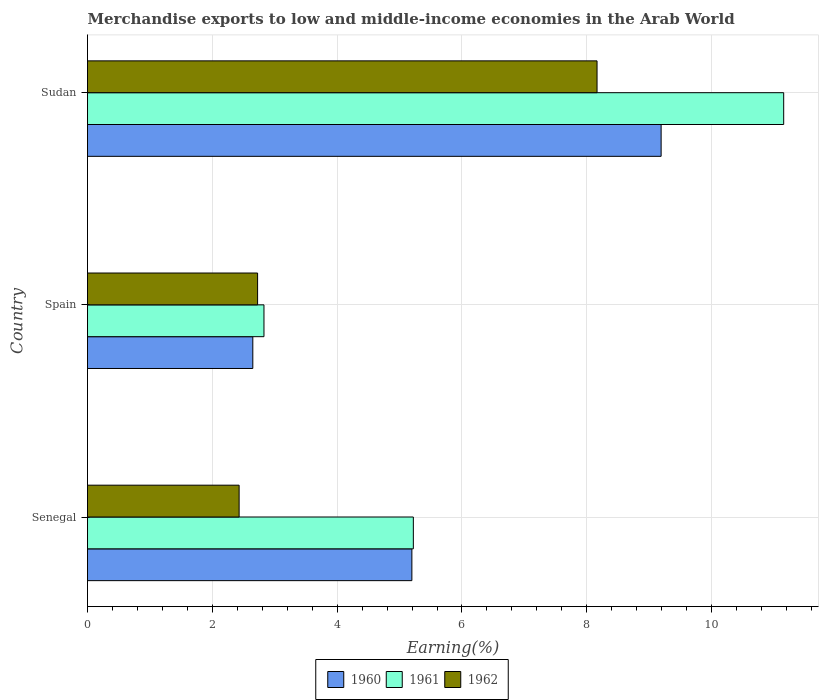Are the number of bars on each tick of the Y-axis equal?
Give a very brief answer. Yes. How many bars are there on the 3rd tick from the top?
Your response must be concise. 3. What is the label of the 1st group of bars from the top?
Your answer should be compact. Sudan. In how many cases, is the number of bars for a given country not equal to the number of legend labels?
Offer a very short reply. 0. What is the percentage of amount earned from merchandise exports in 1960 in Senegal?
Make the answer very short. 5.2. Across all countries, what is the maximum percentage of amount earned from merchandise exports in 1960?
Your answer should be very brief. 9.19. Across all countries, what is the minimum percentage of amount earned from merchandise exports in 1962?
Make the answer very short. 2.43. In which country was the percentage of amount earned from merchandise exports in 1961 maximum?
Your answer should be compact. Sudan. What is the total percentage of amount earned from merchandise exports in 1961 in the graph?
Keep it short and to the point. 19.2. What is the difference between the percentage of amount earned from merchandise exports in 1962 in Senegal and that in Spain?
Give a very brief answer. -0.3. What is the difference between the percentage of amount earned from merchandise exports in 1962 in Sudan and the percentage of amount earned from merchandise exports in 1961 in Senegal?
Offer a very short reply. 2.94. What is the average percentage of amount earned from merchandise exports in 1962 per country?
Offer a very short reply. 4.44. What is the difference between the percentage of amount earned from merchandise exports in 1962 and percentage of amount earned from merchandise exports in 1961 in Sudan?
Provide a short and direct response. -2.99. What is the ratio of the percentage of amount earned from merchandise exports in 1961 in Senegal to that in Sudan?
Make the answer very short. 0.47. Is the percentage of amount earned from merchandise exports in 1962 in Senegal less than that in Sudan?
Keep it short and to the point. Yes. What is the difference between the highest and the second highest percentage of amount earned from merchandise exports in 1961?
Offer a very short reply. 5.93. What is the difference between the highest and the lowest percentage of amount earned from merchandise exports in 1961?
Your answer should be very brief. 8.33. What does the 1st bar from the top in Spain represents?
Your answer should be very brief. 1962. What does the 1st bar from the bottom in Senegal represents?
Provide a succinct answer. 1960. Is it the case that in every country, the sum of the percentage of amount earned from merchandise exports in 1962 and percentage of amount earned from merchandise exports in 1961 is greater than the percentage of amount earned from merchandise exports in 1960?
Offer a very short reply. Yes. How many countries are there in the graph?
Make the answer very short. 3. What is the difference between two consecutive major ticks on the X-axis?
Provide a short and direct response. 2. Where does the legend appear in the graph?
Offer a very short reply. Bottom center. How are the legend labels stacked?
Your answer should be very brief. Horizontal. What is the title of the graph?
Your response must be concise. Merchandise exports to low and middle-income economies in the Arab World. What is the label or title of the X-axis?
Give a very brief answer. Earning(%). What is the Earning(%) of 1960 in Senegal?
Keep it short and to the point. 5.2. What is the Earning(%) of 1961 in Senegal?
Give a very brief answer. 5.22. What is the Earning(%) of 1962 in Senegal?
Keep it short and to the point. 2.43. What is the Earning(%) in 1960 in Spain?
Your answer should be very brief. 2.65. What is the Earning(%) of 1961 in Spain?
Make the answer very short. 2.83. What is the Earning(%) in 1962 in Spain?
Offer a very short reply. 2.73. What is the Earning(%) in 1960 in Sudan?
Your answer should be very brief. 9.19. What is the Earning(%) in 1961 in Sudan?
Offer a terse response. 11.15. What is the Earning(%) of 1962 in Sudan?
Keep it short and to the point. 8.16. Across all countries, what is the maximum Earning(%) in 1960?
Your answer should be compact. 9.19. Across all countries, what is the maximum Earning(%) of 1961?
Offer a very short reply. 11.15. Across all countries, what is the maximum Earning(%) of 1962?
Offer a very short reply. 8.16. Across all countries, what is the minimum Earning(%) of 1960?
Offer a very short reply. 2.65. Across all countries, what is the minimum Earning(%) in 1961?
Keep it short and to the point. 2.83. Across all countries, what is the minimum Earning(%) of 1962?
Your answer should be very brief. 2.43. What is the total Earning(%) in 1960 in the graph?
Keep it short and to the point. 17.04. What is the total Earning(%) of 1961 in the graph?
Your response must be concise. 19.2. What is the total Earning(%) in 1962 in the graph?
Provide a succinct answer. 13.32. What is the difference between the Earning(%) of 1960 in Senegal and that in Spain?
Make the answer very short. 2.55. What is the difference between the Earning(%) in 1961 in Senegal and that in Spain?
Keep it short and to the point. 2.39. What is the difference between the Earning(%) in 1962 in Senegal and that in Spain?
Your answer should be compact. -0.3. What is the difference between the Earning(%) in 1960 in Senegal and that in Sudan?
Provide a succinct answer. -3.99. What is the difference between the Earning(%) of 1961 in Senegal and that in Sudan?
Provide a short and direct response. -5.93. What is the difference between the Earning(%) of 1962 in Senegal and that in Sudan?
Make the answer very short. -5.74. What is the difference between the Earning(%) of 1960 in Spain and that in Sudan?
Keep it short and to the point. -6.54. What is the difference between the Earning(%) in 1961 in Spain and that in Sudan?
Provide a succinct answer. -8.33. What is the difference between the Earning(%) in 1962 in Spain and that in Sudan?
Make the answer very short. -5.44. What is the difference between the Earning(%) of 1960 in Senegal and the Earning(%) of 1961 in Spain?
Your answer should be compact. 2.37. What is the difference between the Earning(%) in 1960 in Senegal and the Earning(%) in 1962 in Spain?
Provide a succinct answer. 2.47. What is the difference between the Earning(%) in 1961 in Senegal and the Earning(%) in 1962 in Spain?
Provide a succinct answer. 2.5. What is the difference between the Earning(%) of 1960 in Senegal and the Earning(%) of 1961 in Sudan?
Provide a short and direct response. -5.96. What is the difference between the Earning(%) in 1960 in Senegal and the Earning(%) in 1962 in Sudan?
Offer a very short reply. -2.97. What is the difference between the Earning(%) in 1961 in Senegal and the Earning(%) in 1962 in Sudan?
Provide a succinct answer. -2.94. What is the difference between the Earning(%) of 1960 in Spain and the Earning(%) of 1961 in Sudan?
Ensure brevity in your answer.  -8.51. What is the difference between the Earning(%) in 1960 in Spain and the Earning(%) in 1962 in Sudan?
Make the answer very short. -5.52. What is the difference between the Earning(%) of 1961 in Spain and the Earning(%) of 1962 in Sudan?
Provide a short and direct response. -5.34. What is the average Earning(%) of 1960 per country?
Give a very brief answer. 5.68. What is the average Earning(%) in 1961 per country?
Offer a very short reply. 6.4. What is the average Earning(%) of 1962 per country?
Your answer should be very brief. 4.44. What is the difference between the Earning(%) of 1960 and Earning(%) of 1961 in Senegal?
Ensure brevity in your answer.  -0.02. What is the difference between the Earning(%) in 1960 and Earning(%) in 1962 in Senegal?
Provide a succinct answer. 2.77. What is the difference between the Earning(%) of 1961 and Earning(%) of 1962 in Senegal?
Make the answer very short. 2.79. What is the difference between the Earning(%) in 1960 and Earning(%) in 1961 in Spain?
Your answer should be very brief. -0.18. What is the difference between the Earning(%) of 1960 and Earning(%) of 1962 in Spain?
Offer a very short reply. -0.08. What is the difference between the Earning(%) in 1961 and Earning(%) in 1962 in Spain?
Offer a very short reply. 0.1. What is the difference between the Earning(%) in 1960 and Earning(%) in 1961 in Sudan?
Offer a terse response. -1.96. What is the difference between the Earning(%) in 1960 and Earning(%) in 1962 in Sudan?
Make the answer very short. 1.03. What is the difference between the Earning(%) in 1961 and Earning(%) in 1962 in Sudan?
Provide a succinct answer. 2.99. What is the ratio of the Earning(%) of 1960 in Senegal to that in Spain?
Your answer should be compact. 1.96. What is the ratio of the Earning(%) of 1961 in Senegal to that in Spain?
Ensure brevity in your answer.  1.85. What is the ratio of the Earning(%) in 1962 in Senegal to that in Spain?
Provide a short and direct response. 0.89. What is the ratio of the Earning(%) of 1960 in Senegal to that in Sudan?
Provide a succinct answer. 0.57. What is the ratio of the Earning(%) in 1961 in Senegal to that in Sudan?
Give a very brief answer. 0.47. What is the ratio of the Earning(%) in 1962 in Senegal to that in Sudan?
Offer a terse response. 0.3. What is the ratio of the Earning(%) in 1960 in Spain to that in Sudan?
Offer a very short reply. 0.29. What is the ratio of the Earning(%) in 1961 in Spain to that in Sudan?
Provide a short and direct response. 0.25. What is the ratio of the Earning(%) in 1962 in Spain to that in Sudan?
Make the answer very short. 0.33. What is the difference between the highest and the second highest Earning(%) in 1960?
Offer a terse response. 3.99. What is the difference between the highest and the second highest Earning(%) in 1961?
Make the answer very short. 5.93. What is the difference between the highest and the second highest Earning(%) of 1962?
Offer a terse response. 5.44. What is the difference between the highest and the lowest Earning(%) in 1960?
Provide a succinct answer. 6.54. What is the difference between the highest and the lowest Earning(%) of 1961?
Keep it short and to the point. 8.33. What is the difference between the highest and the lowest Earning(%) of 1962?
Your response must be concise. 5.74. 